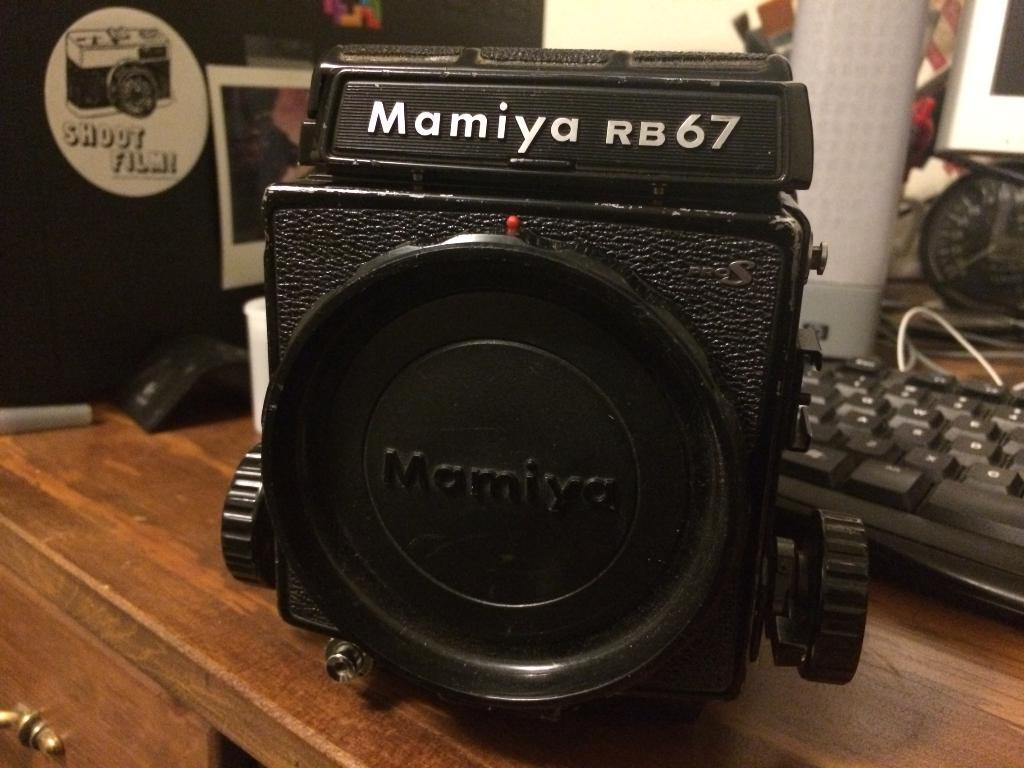<image>
Render a clear and concise summary of the photo. the word Mamiya is on the black camera 